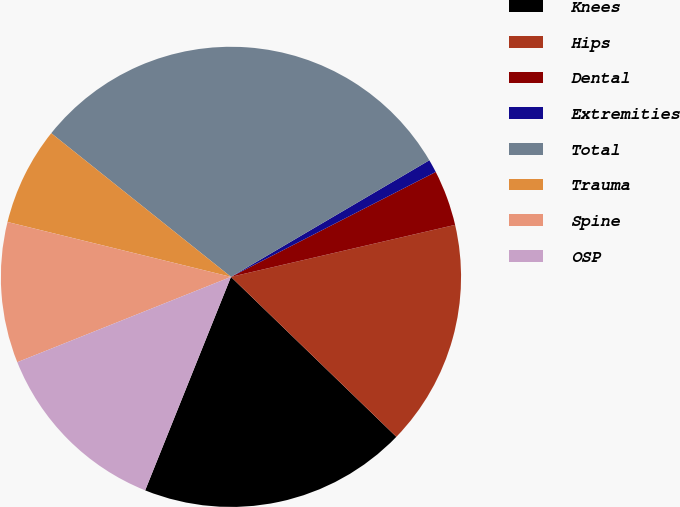<chart> <loc_0><loc_0><loc_500><loc_500><pie_chart><fcel>Knees<fcel>Hips<fcel>Dental<fcel>Extremities<fcel>Total<fcel>Trauma<fcel>Spine<fcel>OSP<nl><fcel>18.85%<fcel>15.86%<fcel>3.91%<fcel>0.92%<fcel>30.81%<fcel>6.9%<fcel>9.88%<fcel>12.87%<nl></chart> 